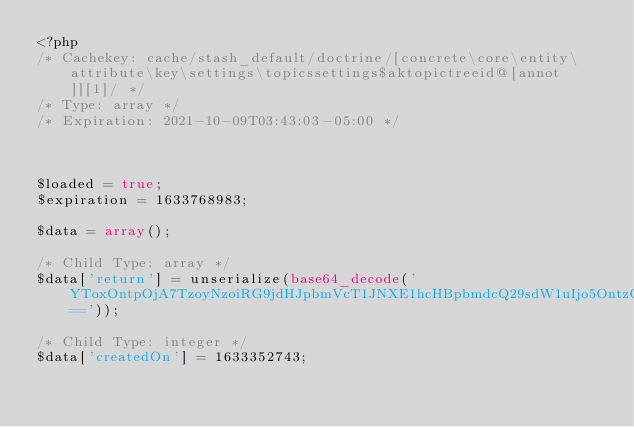<code> <loc_0><loc_0><loc_500><loc_500><_PHP_><?php 
/* Cachekey: cache/stash_default/doctrine/[concrete\core\entity\attribute\key\settings\topicssettings$aktopictreeid@[annot]][1]/ */
/* Type: array */
/* Expiration: 2021-10-09T03:43:03-05:00 */



$loaded = true;
$expiration = 1633768983;

$data = array();

/* Child Type: array */
$data['return'] = unserialize(base64_decode('YToxOntpOjA7TzoyNzoiRG9jdHJpbmVcT1JNXE1hcHBpbmdcQ29sdW1uIjo5OntzOjQ6Im5hbWUiO047czo0OiJ0eXBlIjtzOjc6ImludGVnZXIiO3M6NjoibGVuZ3RoIjtOO3M6OToicHJlY2lzaW9uIjtpOjA7czo1OiJzY2FsZSI7aTowO3M6NjoidW5pcXVlIjtiOjA7czo4OiJudWxsYWJsZSI7YjowO3M6Nzoib3B0aW9ucyI7YTowOnt9czoxNjoiY29sdW1uRGVmaW5pdGlvbiI7Tjt9fQ=='));

/* Child Type: integer */
$data['createdOn'] = 1633352743;
</code> 